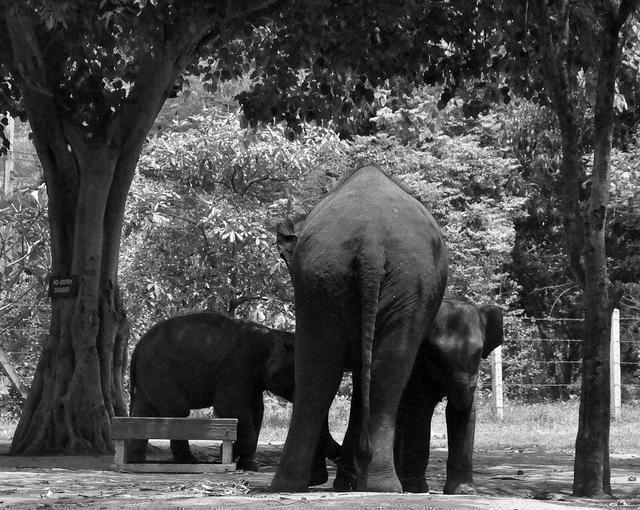What are the Elephants standing on?
From the following four choices, select the correct answer to address the question.
Options: Sticks, water, concrete, snow. Concrete. 